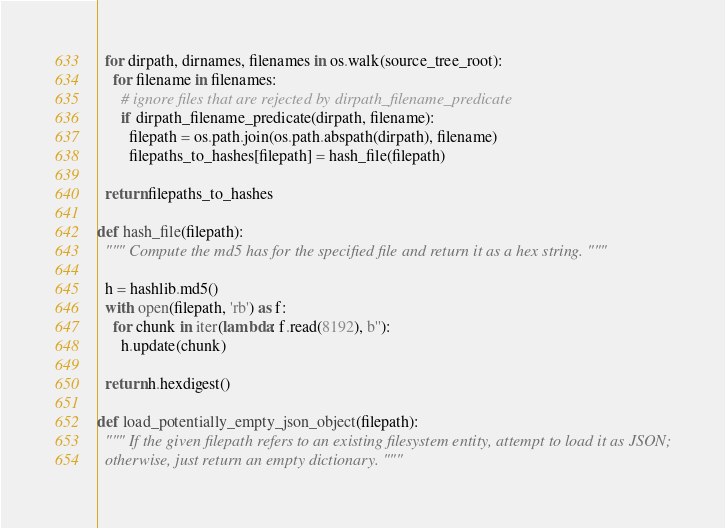<code> <loc_0><loc_0><loc_500><loc_500><_Python_>  for dirpath, dirnames, filenames in os.walk(source_tree_root):
    for filename in filenames:
      # ignore files that are rejected by dirpath_filename_predicate
      if dirpath_filename_predicate(dirpath, filename):
        filepath = os.path.join(os.path.abspath(dirpath), filename)
        filepaths_to_hashes[filepath] = hash_file(filepath)

  return filepaths_to_hashes

def hash_file(filepath):
  """ Compute the md5 has for the specified file and return it as a hex string. """

  h = hashlib.md5()
  with open(filepath, 'rb') as f:
    for chunk in iter(lambda: f.read(8192), b''):
      h.update(chunk)

  return h.hexdigest()

def load_potentially_empty_json_object(filepath):
  """ If the given filepath refers to an existing filesystem entity, attempt to load it as JSON;
  otherwise, just return an empty dictionary. """
</code> 